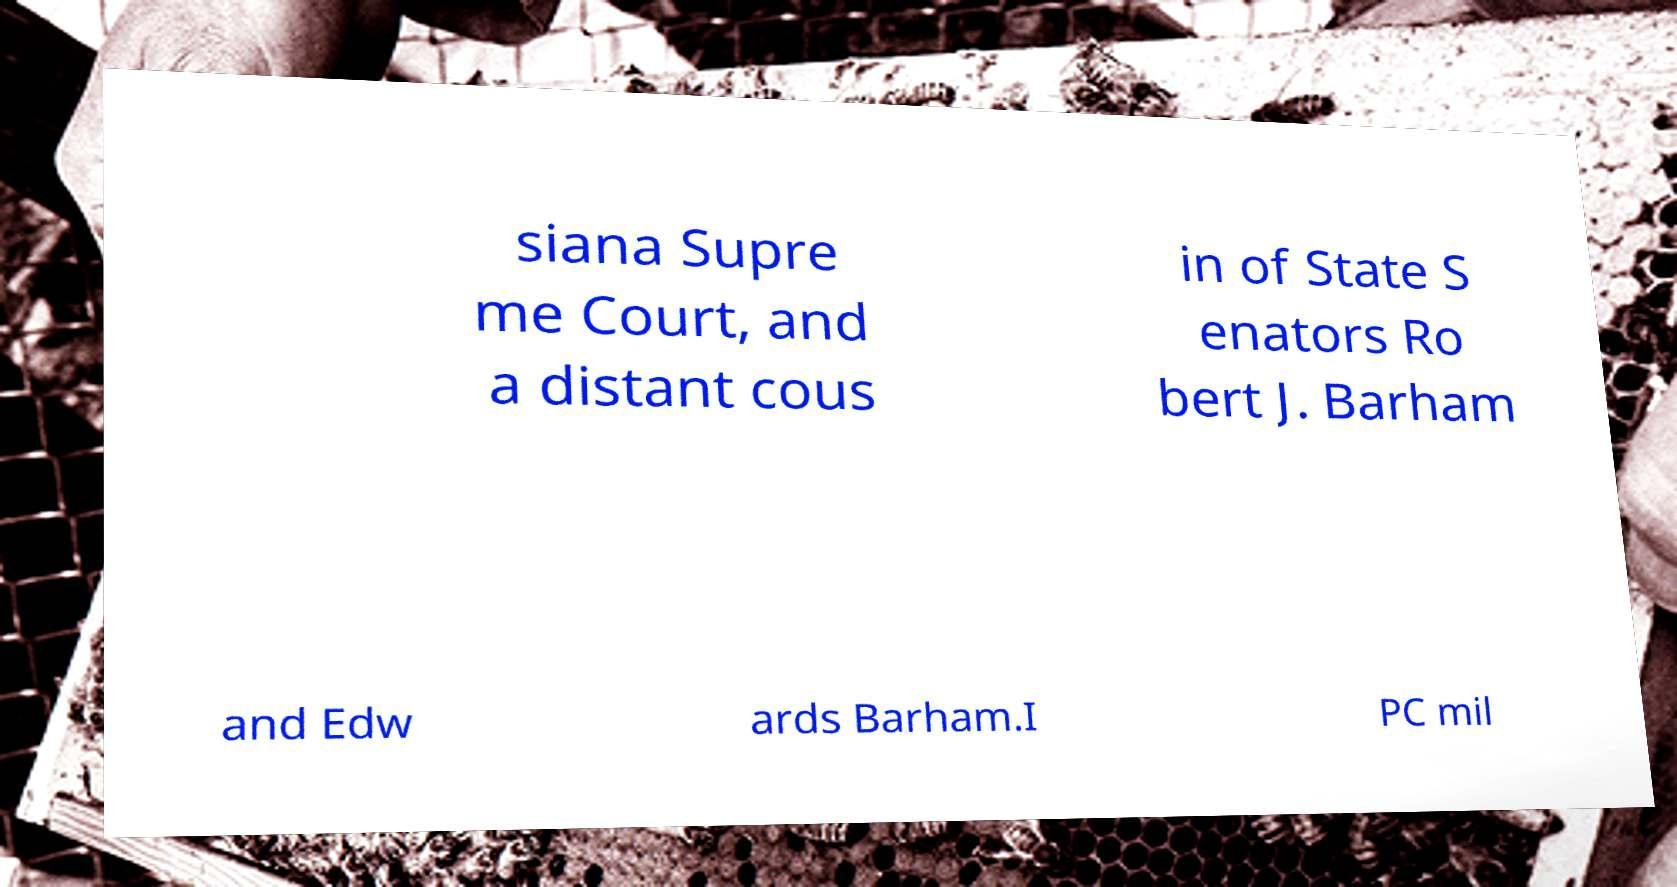Can you accurately transcribe the text from the provided image for me? siana Supre me Court, and a distant cous in of State S enators Ro bert J. Barham and Edw ards Barham.I PC mil 